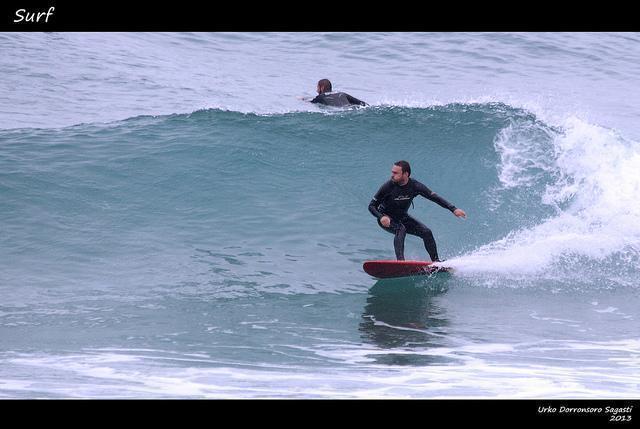Why does the man on the surf board crouch?
From the following set of four choices, select the accurate answer to respond to the question.
Options: Stealth hiding, shark sighting, improved balance, he's falling. Improved balance. 